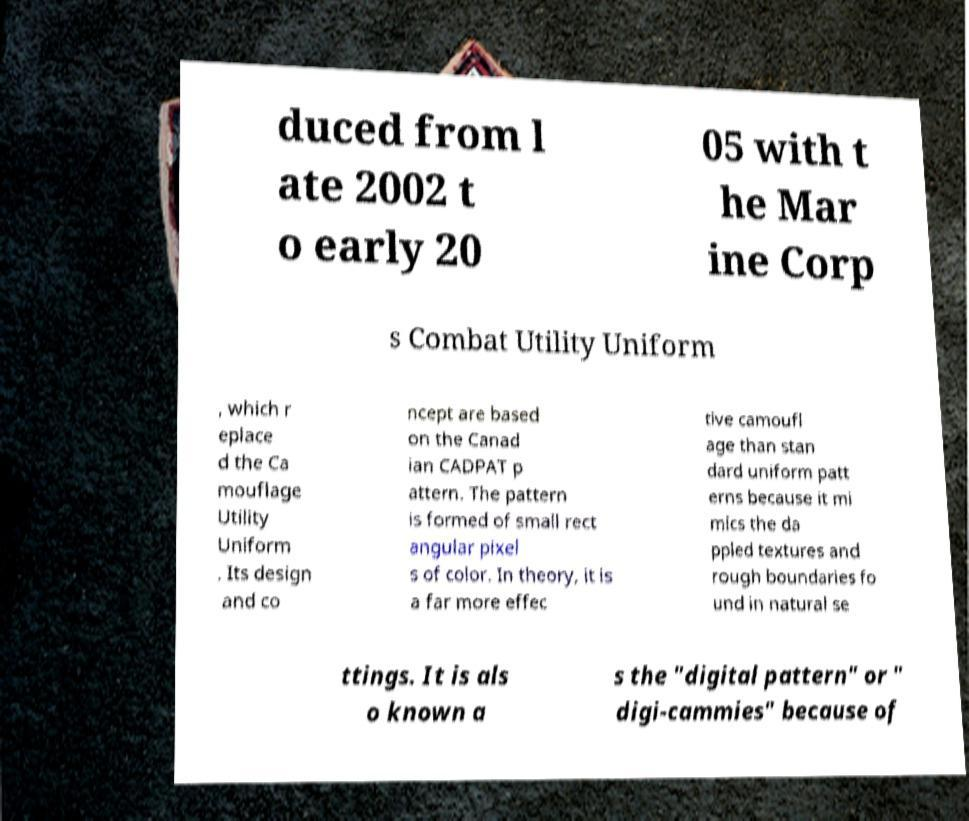There's text embedded in this image that I need extracted. Can you transcribe it verbatim? duced from l ate 2002 t o early 20 05 with t he Mar ine Corp s Combat Utility Uniform , which r eplace d the Ca mouflage Utility Uniform . Its design and co ncept are based on the Canad ian CADPAT p attern. The pattern is formed of small rect angular pixel s of color. In theory, it is a far more effec tive camoufl age than stan dard uniform patt erns because it mi mics the da ppled textures and rough boundaries fo und in natural se ttings. It is als o known a s the "digital pattern" or " digi-cammies" because of 